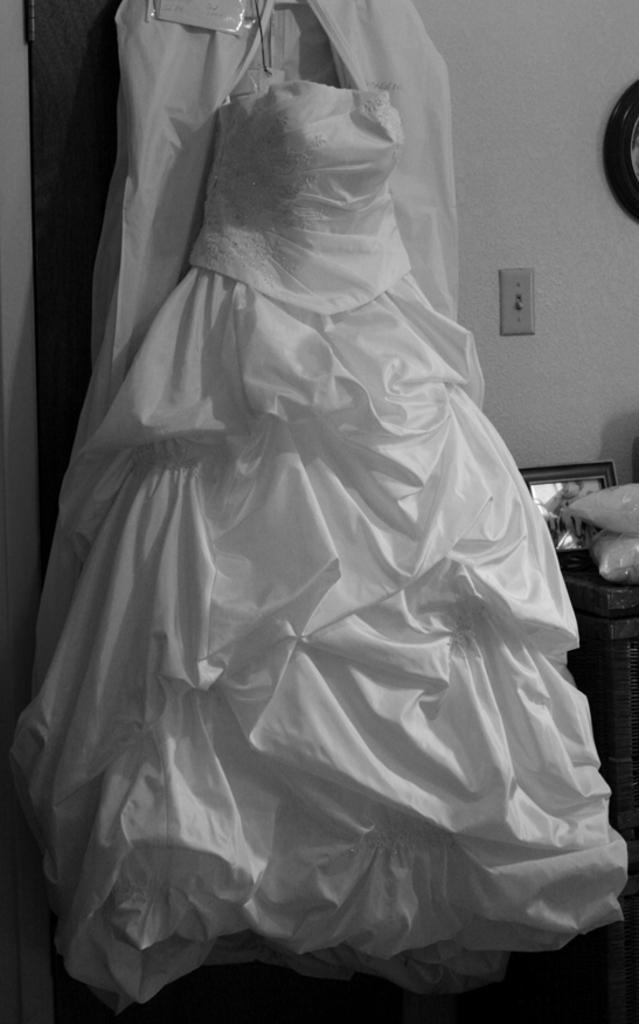Can you describe this image briefly? In this image we can see white color sheet and in the background of the image there is wall, mirror and switch socket. 